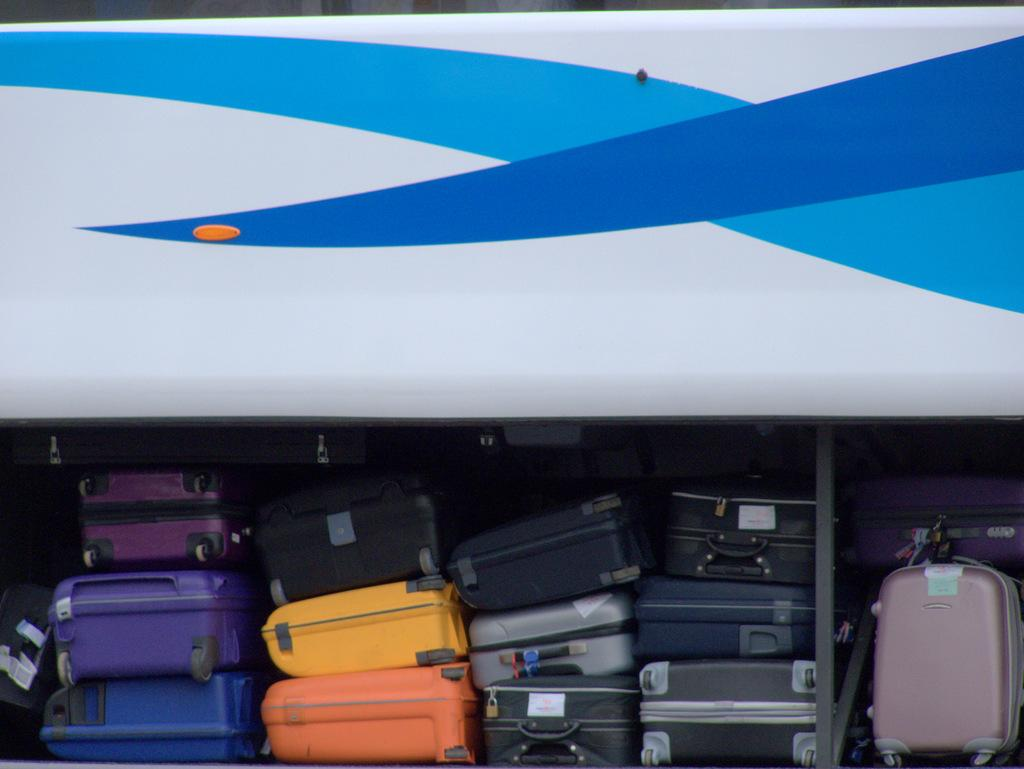What type of items can be seen in the image? There are colorful luggage in the image. Where are the luggage located? The luggage is in a vehicle. What is the color of the vehicle? The vehicle is in white and blue color. What type of band is performing in the image? There is no band present in the image; it features colorful luggage in a vehicle. What route is the vehicle taking in the image? The image does not show the vehicle in motion or provide any information about its route. 